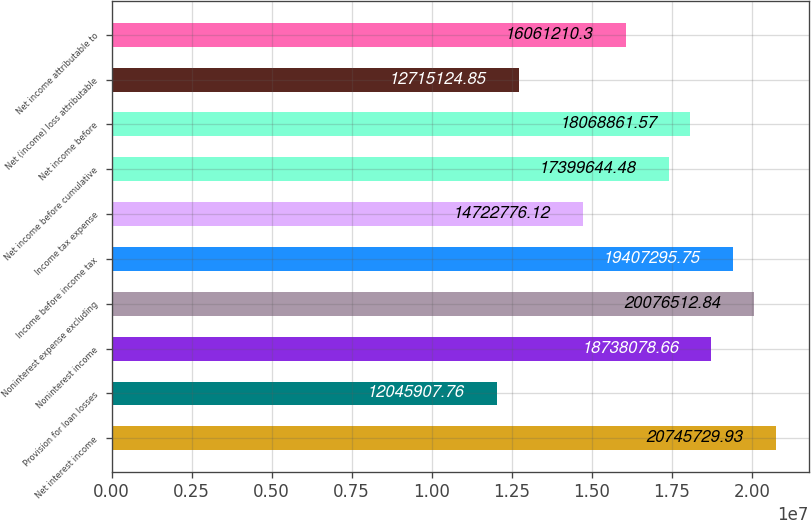<chart> <loc_0><loc_0><loc_500><loc_500><bar_chart><fcel>Net interest income<fcel>Provision for loan losses<fcel>Noninterest income<fcel>Noninterest expense excluding<fcel>Income before income tax<fcel>Income tax expense<fcel>Net income before cumulative<fcel>Net income before<fcel>Net (income) loss attributable<fcel>Net income attributable to<nl><fcel>2.07457e+07<fcel>1.20459e+07<fcel>1.87381e+07<fcel>2.00765e+07<fcel>1.94073e+07<fcel>1.47228e+07<fcel>1.73996e+07<fcel>1.80689e+07<fcel>1.27151e+07<fcel>1.60612e+07<nl></chart> 